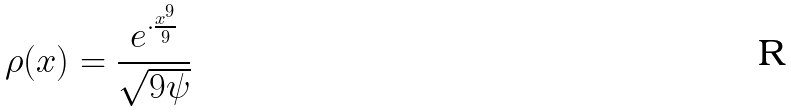<formula> <loc_0><loc_0><loc_500><loc_500>\rho ( x ) = \frac { e ^ { \cdot \frac { x ^ { 9 } } { 9 } } } { \sqrt { 9 \psi } }</formula> 